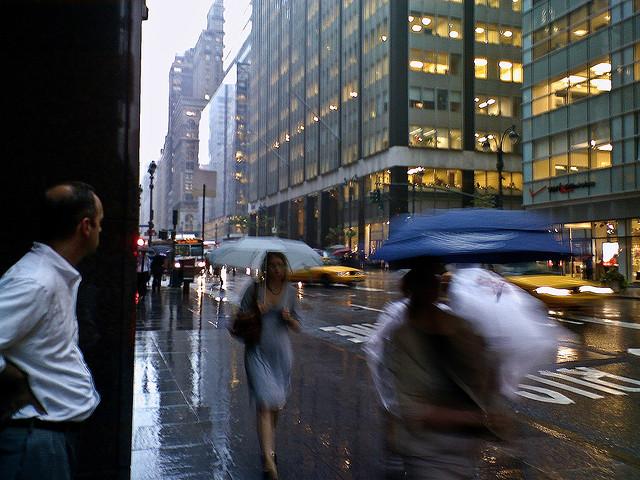Are the lights on in the buildings?
Be succinct. Yes. Is the weather nice?
Be succinct. No. What object are people holding to protect themselves from rain?
Concise answer only. Umbrella. 